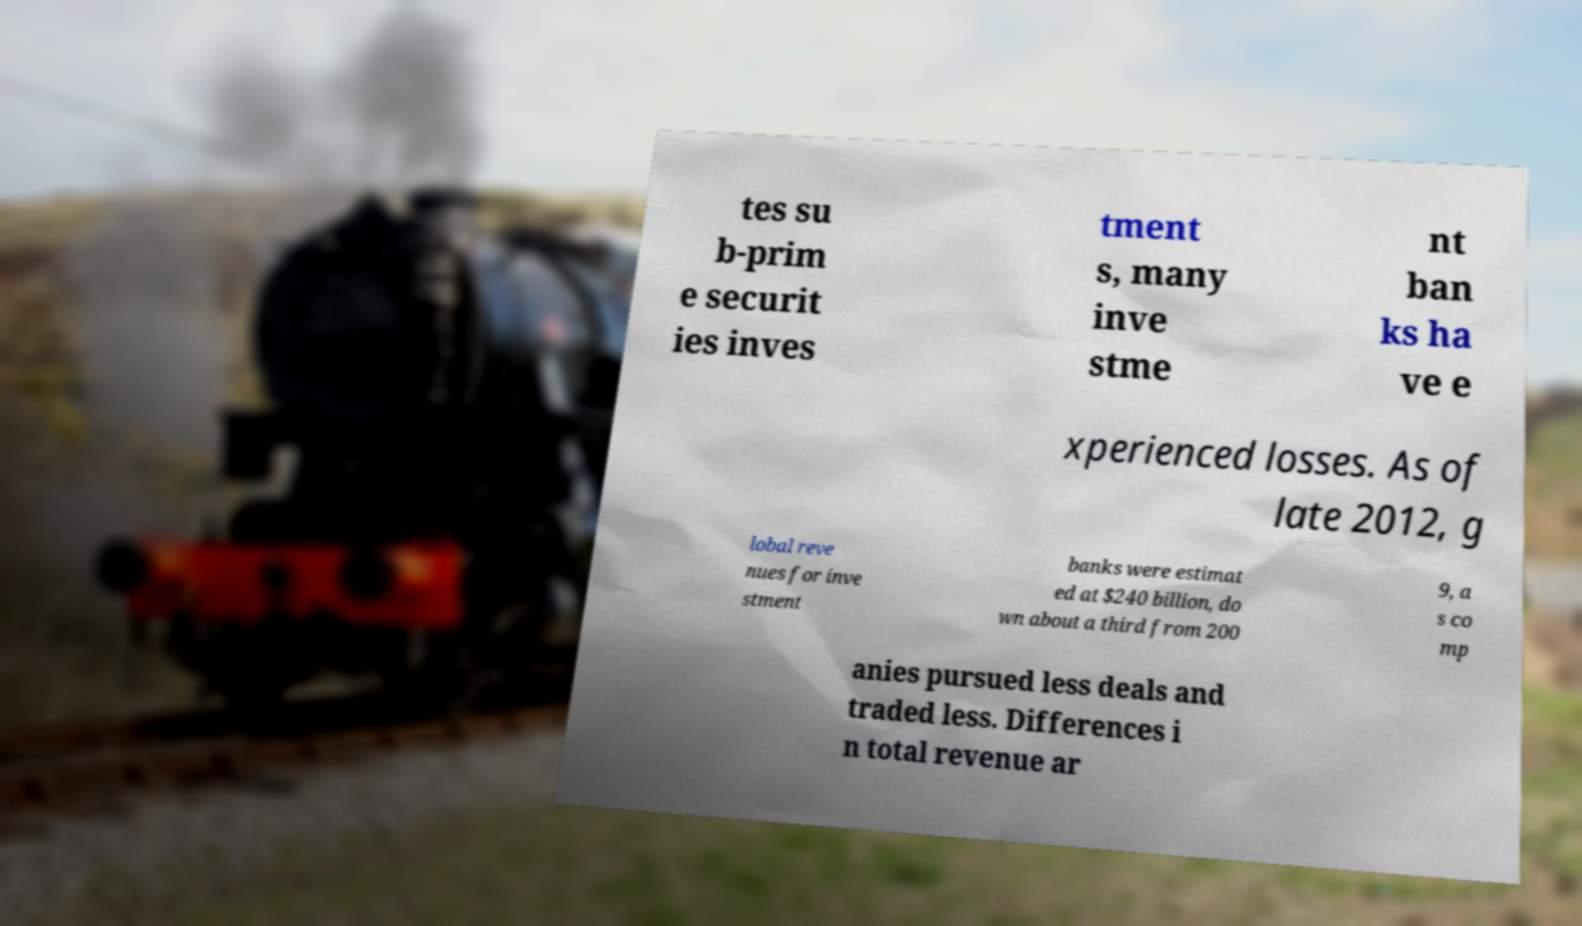Could you extract and type out the text from this image? tes su b-prim e securit ies inves tment s, many inve stme nt ban ks ha ve e xperienced losses. As of late 2012, g lobal reve nues for inve stment banks were estimat ed at $240 billion, do wn about a third from 200 9, a s co mp anies pursued less deals and traded less. Differences i n total revenue ar 